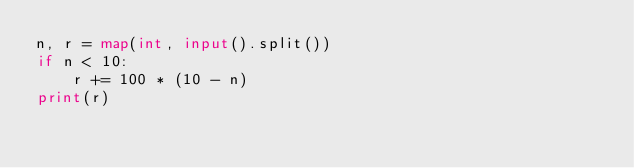<code> <loc_0><loc_0><loc_500><loc_500><_Python_>n, r = map(int, input().split())
if n < 10:
    r += 100 * (10 - n)
print(r)</code> 